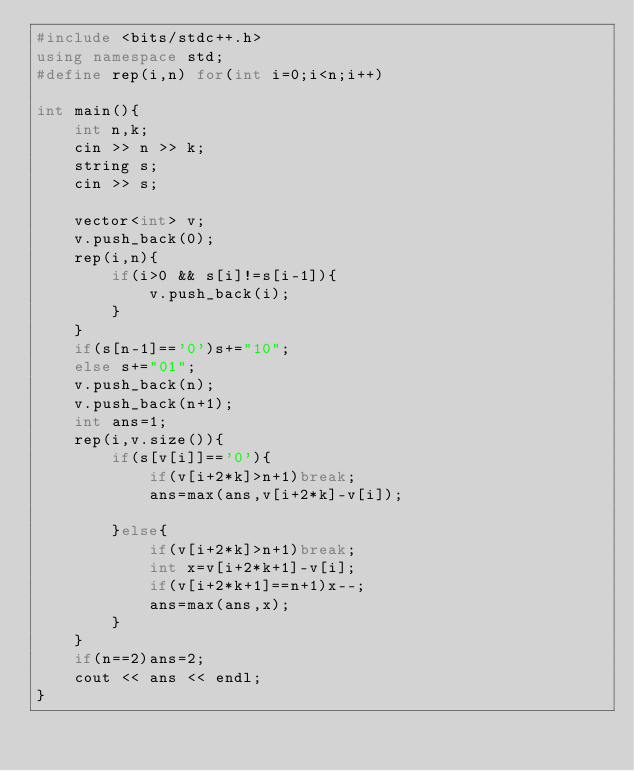<code> <loc_0><loc_0><loc_500><loc_500><_C++_>#include <bits/stdc++.h>
using namespace std;
#define rep(i,n) for(int i=0;i<n;i++)

int main(){
    int n,k;
    cin >> n >> k;
    string s;
    cin >> s;

    vector<int> v;
    v.push_back(0);
    rep(i,n){
        if(i>0 && s[i]!=s[i-1]){
            v.push_back(i);
        }
    }
    if(s[n-1]=='0')s+="10";
    else s+="01";
    v.push_back(n);
    v.push_back(n+1);
    int ans=1;
    rep(i,v.size()){    
        if(s[v[i]]=='0'){
            if(v[i+2*k]>n+1)break;
            ans=max(ans,v[i+2*k]-v[i]);

        }else{
            if(v[i+2*k]>n+1)break;
            int x=v[i+2*k+1]-v[i];
            if(v[i+2*k+1]==n+1)x--;
            ans=max(ans,x);
        }
    }
    if(n==2)ans=2;
    cout << ans << endl;
}</code> 